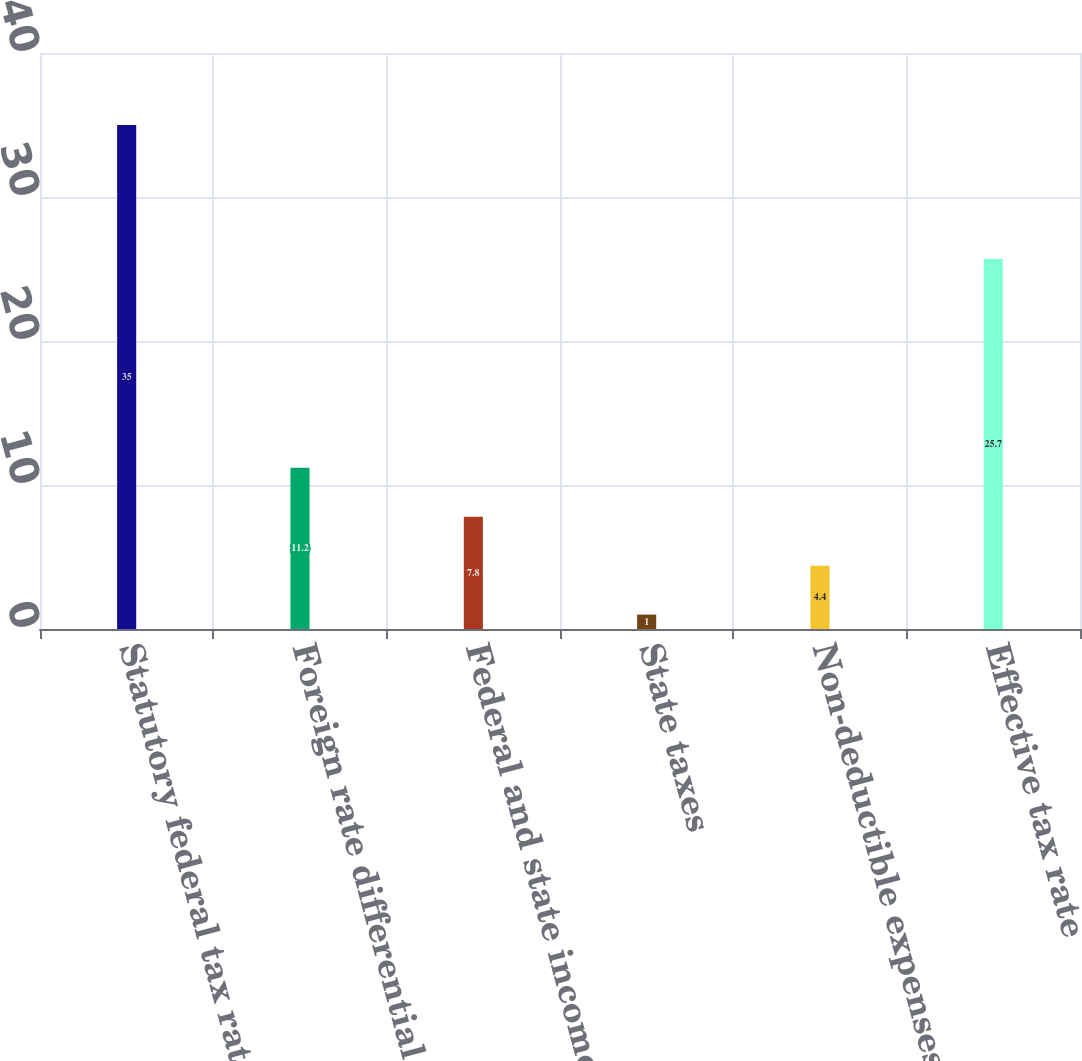Convert chart to OTSL. <chart><loc_0><loc_0><loc_500><loc_500><bar_chart><fcel>Statutory federal tax rate<fcel>Foreign rate differential<fcel>Federal and state income tax<fcel>State taxes<fcel>Non-deductible expenses<fcel>Effective tax rate<nl><fcel>35<fcel>11.2<fcel>7.8<fcel>1<fcel>4.4<fcel>25.7<nl></chart> 